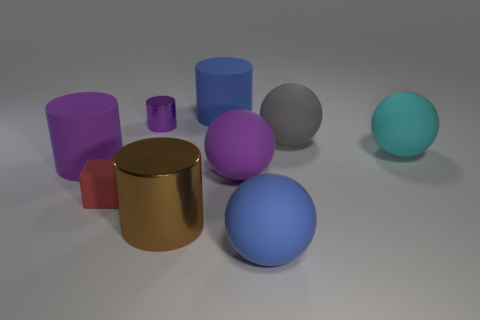Subtract all blue spheres. How many spheres are left? 3 Subtract all cyan spheres. How many spheres are left? 3 Subtract all cubes. How many objects are left? 8 Subtract 2 balls. How many balls are left? 2 Add 1 tiny gray matte cylinders. How many objects exist? 10 Subtract all gray cylinders. How many gray spheres are left? 1 Subtract all tiny yellow rubber things. Subtract all matte spheres. How many objects are left? 5 Add 3 brown cylinders. How many brown cylinders are left? 4 Add 1 big blue matte cubes. How many big blue matte cubes exist? 1 Subtract 2 purple cylinders. How many objects are left? 7 